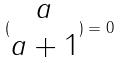<formula> <loc_0><loc_0><loc_500><loc_500>( \begin{matrix} a \\ a + 1 \end{matrix} ) = 0</formula> 